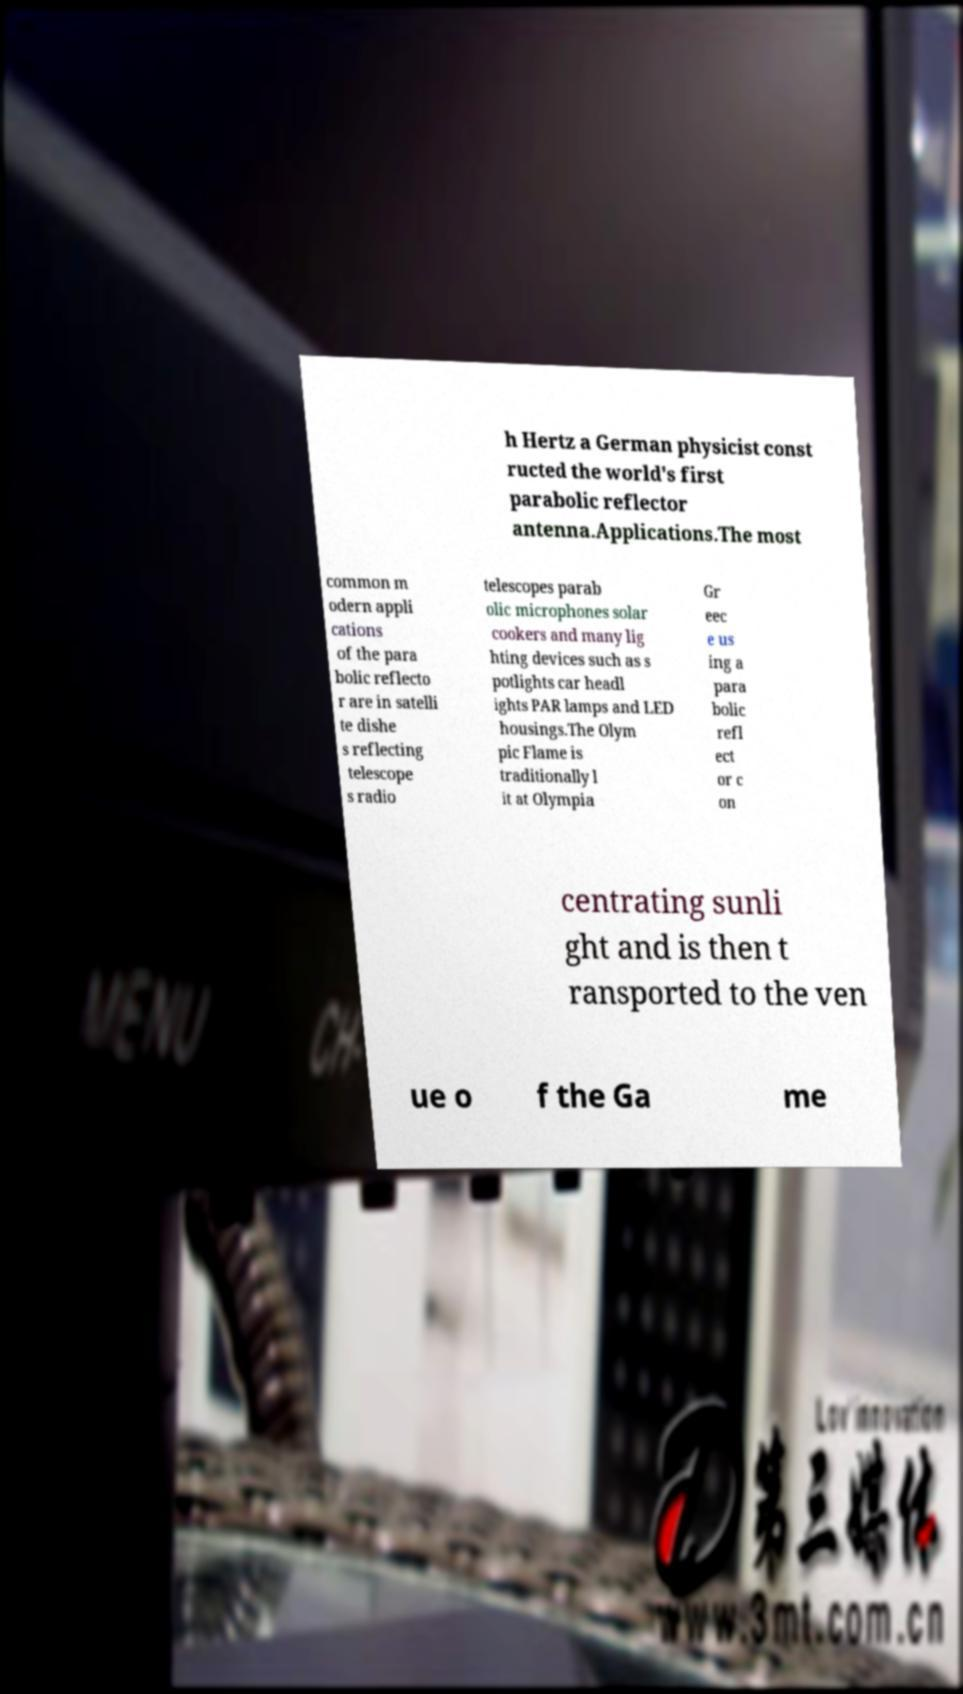For documentation purposes, I need the text within this image transcribed. Could you provide that? h Hertz a German physicist const ructed the world's first parabolic reflector antenna.Applications.The most common m odern appli cations of the para bolic reflecto r are in satelli te dishe s reflecting telescope s radio telescopes parab olic microphones solar cookers and many lig hting devices such as s potlights car headl ights PAR lamps and LED housings.The Olym pic Flame is traditionally l it at Olympia Gr eec e us ing a para bolic refl ect or c on centrating sunli ght and is then t ransported to the ven ue o f the Ga me 